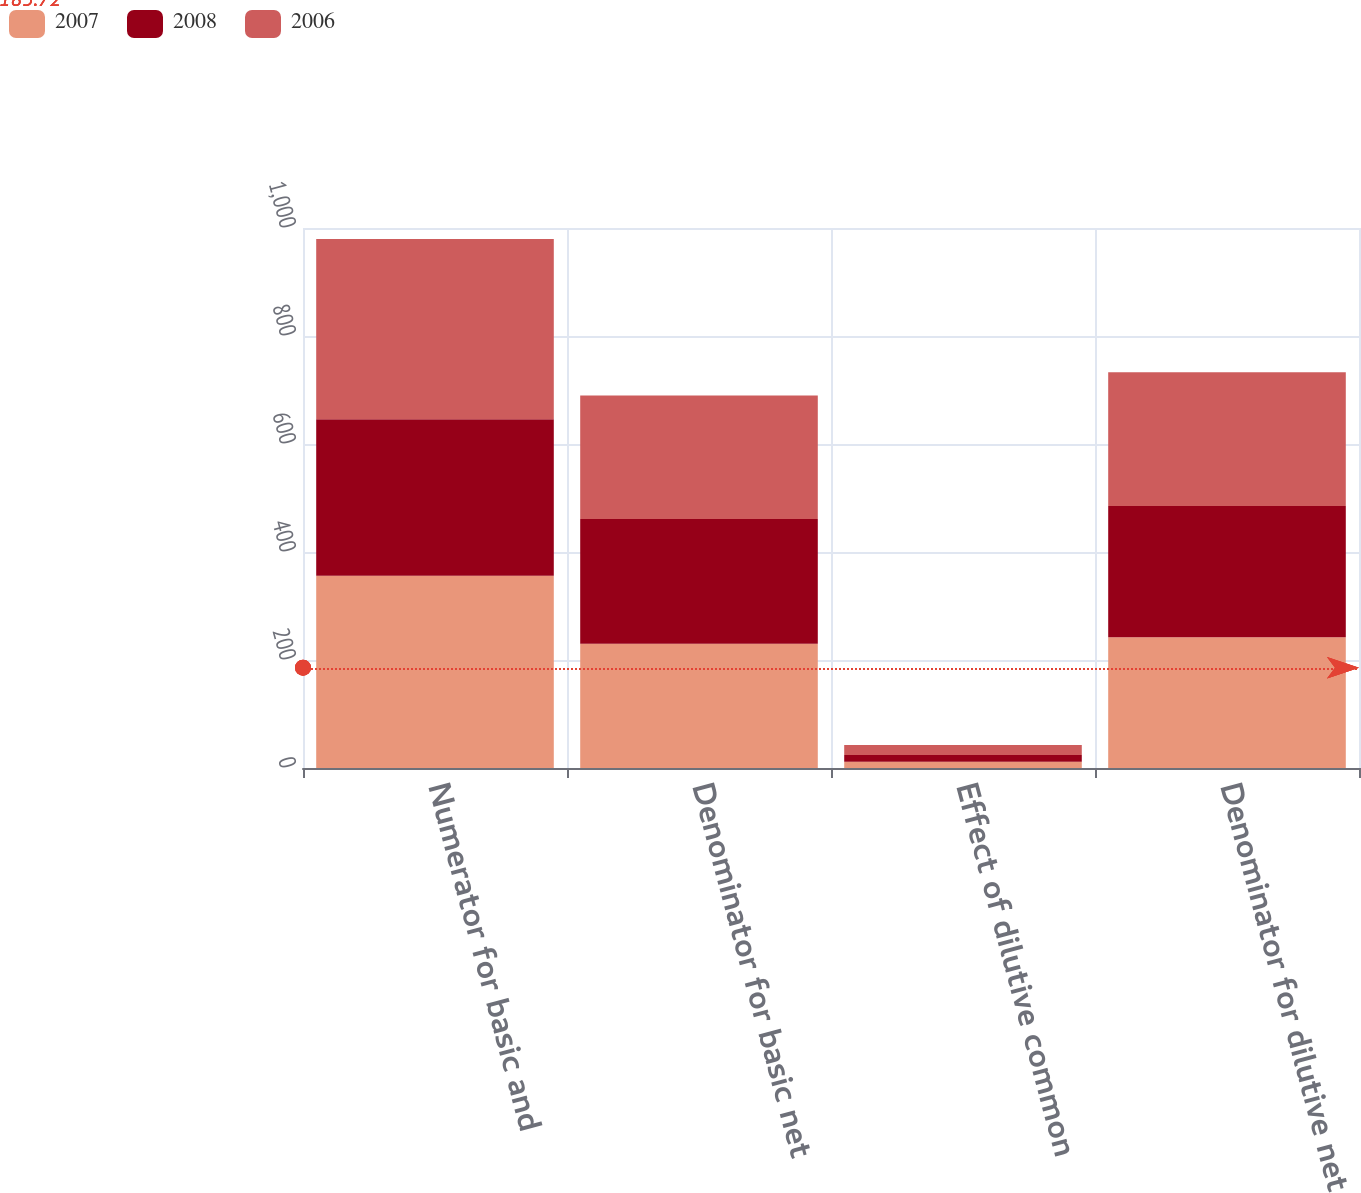<chart> <loc_0><loc_0><loc_500><loc_500><stacked_bar_chart><ecel><fcel>Numerator for basic and<fcel>Denominator for basic net<fcel>Effect of dilutive common<fcel>Denominator for dilutive net<nl><fcel>2007<fcel>356.2<fcel>230.3<fcel>11.7<fcel>242<nl><fcel>2008<fcel>289.7<fcel>230.7<fcel>12.5<fcel>243.2<nl><fcel>2006<fcel>333.6<fcel>229<fcel>18.5<fcel>247.5<nl></chart> 